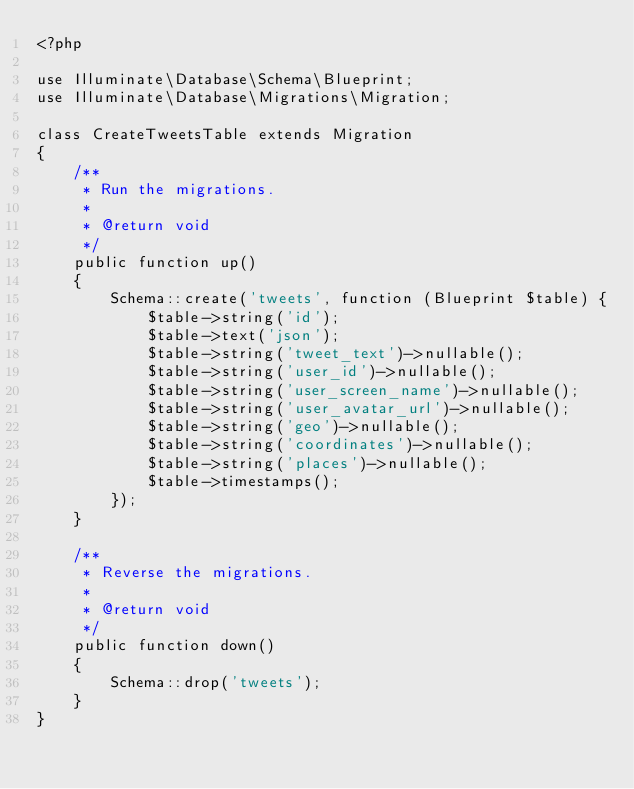Convert code to text. <code><loc_0><loc_0><loc_500><loc_500><_PHP_><?php

use Illuminate\Database\Schema\Blueprint;
use Illuminate\Database\Migrations\Migration;

class CreateTweetsTable extends Migration
{
    /**
     * Run the migrations.
     *
     * @return void
     */
    public function up()
    {
        Schema::create('tweets', function (Blueprint $table) {
            $table->string('id');
            $table->text('json');
            $table->string('tweet_text')->nullable();
            $table->string('user_id')->nullable();
            $table->string('user_screen_name')->nullable();
            $table->string('user_avatar_url')->nullable();
            $table->string('geo')->nullable();
            $table->string('coordinates')->nullable();
            $table->string('places')->nullable();
            $table->timestamps();
        });
    }

    /**
     * Reverse the migrations.
     *
     * @return void
     */
    public function down()
    {
        Schema::drop('tweets');
    }
}
</code> 